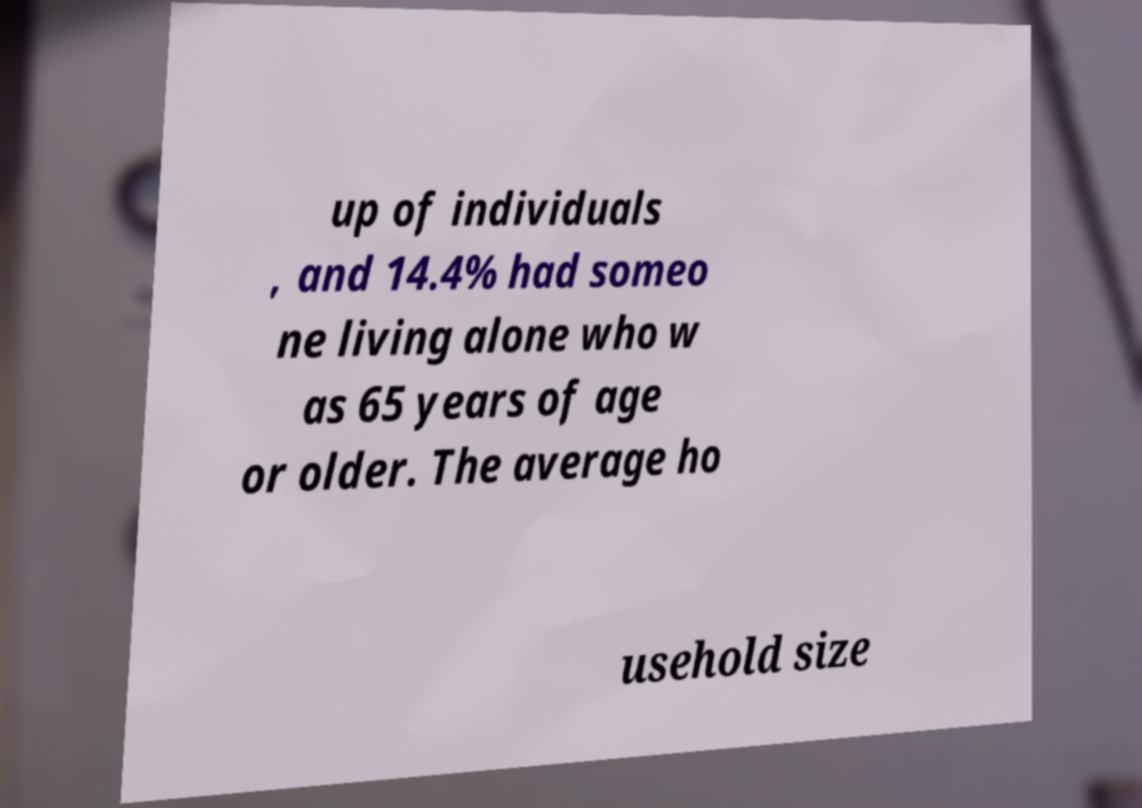Can you read and provide the text displayed in the image?This photo seems to have some interesting text. Can you extract and type it out for me? up of individuals , and 14.4% had someo ne living alone who w as 65 years of age or older. The average ho usehold size 